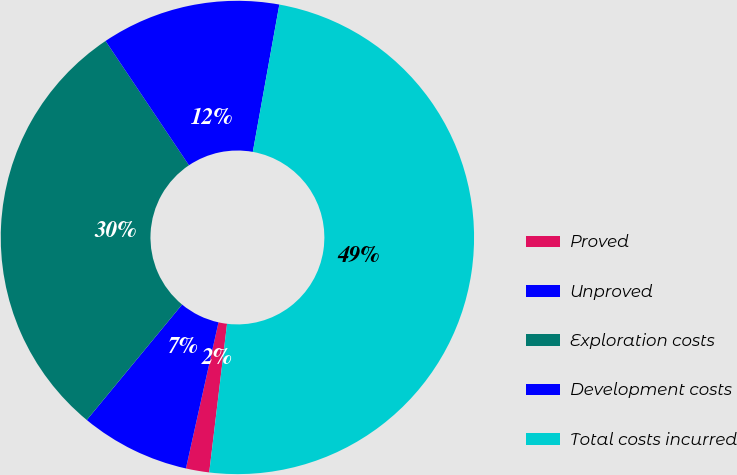Convert chart to OTSL. <chart><loc_0><loc_0><loc_500><loc_500><pie_chart><fcel>Proved<fcel>Unproved<fcel>Exploration costs<fcel>Development costs<fcel>Total costs incurred<nl><fcel>1.59%<fcel>7.49%<fcel>29.61%<fcel>12.24%<fcel>49.06%<nl></chart> 